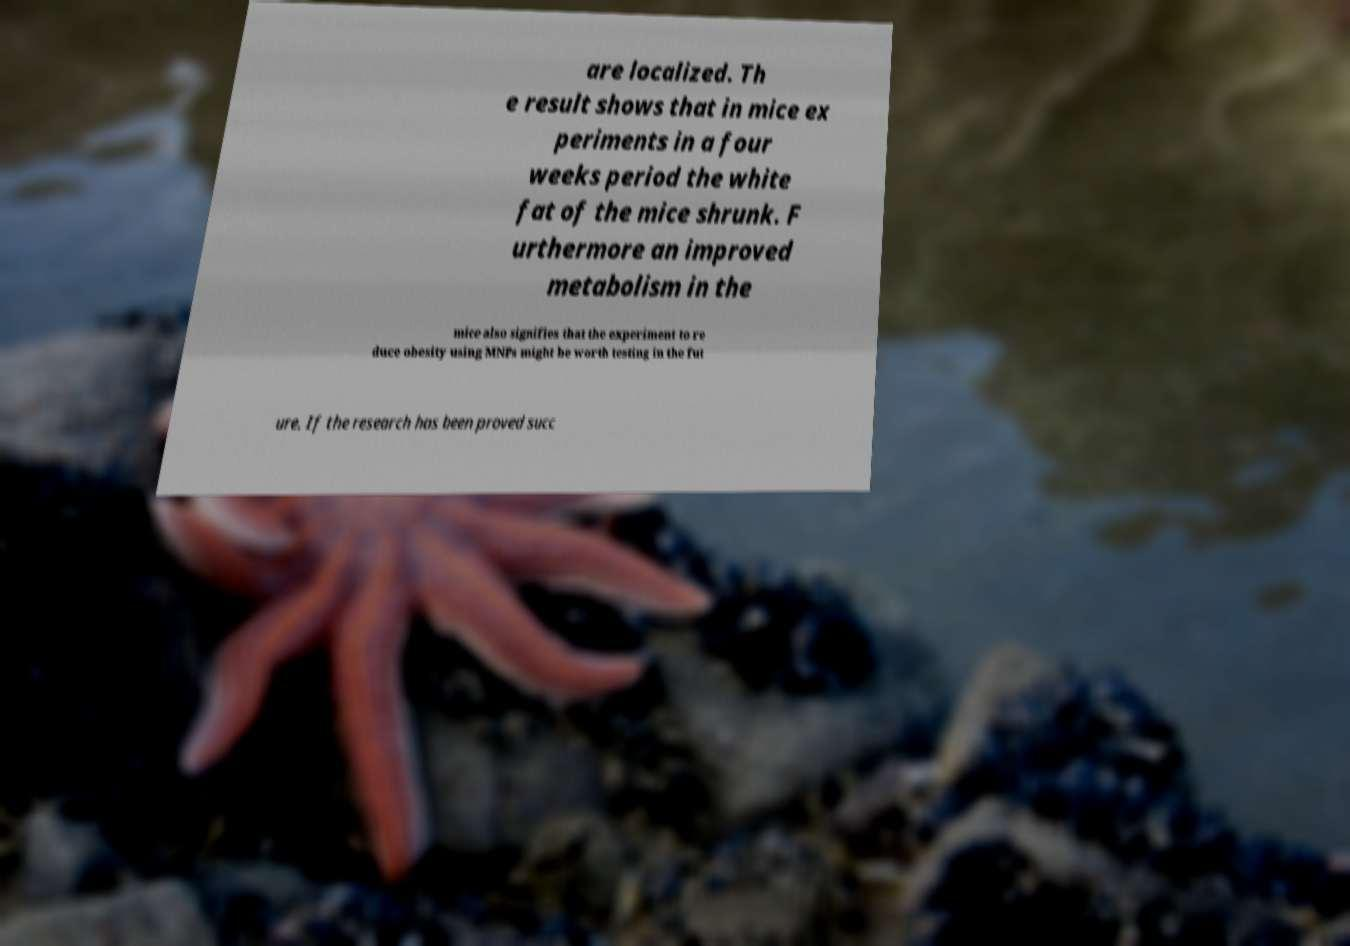Please identify and transcribe the text found in this image. are localized. Th e result shows that in mice ex periments in a four weeks period the white fat of the mice shrunk. F urthermore an improved metabolism in the mice also signifies that the experiment to re duce obesity using MNPs might be worth testing in the fut ure. If the research has been proved succ 